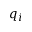<formula> <loc_0><loc_0><loc_500><loc_500>q _ { i }</formula> 